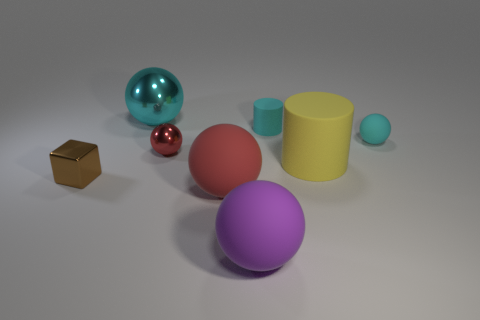Subtract all cyan balls. How many balls are left? 3 Subtract all purple matte spheres. How many spheres are left? 4 Add 2 small cylinders. How many objects exist? 10 Subtract all yellow balls. Subtract all cyan cubes. How many balls are left? 5 Subtract all cylinders. How many objects are left? 6 Subtract 0 purple cylinders. How many objects are left? 8 Subtract all blue shiny spheres. Subtract all large cyan shiny objects. How many objects are left? 7 Add 3 large matte things. How many large matte things are left? 6 Add 6 large red rubber things. How many large red rubber things exist? 7 